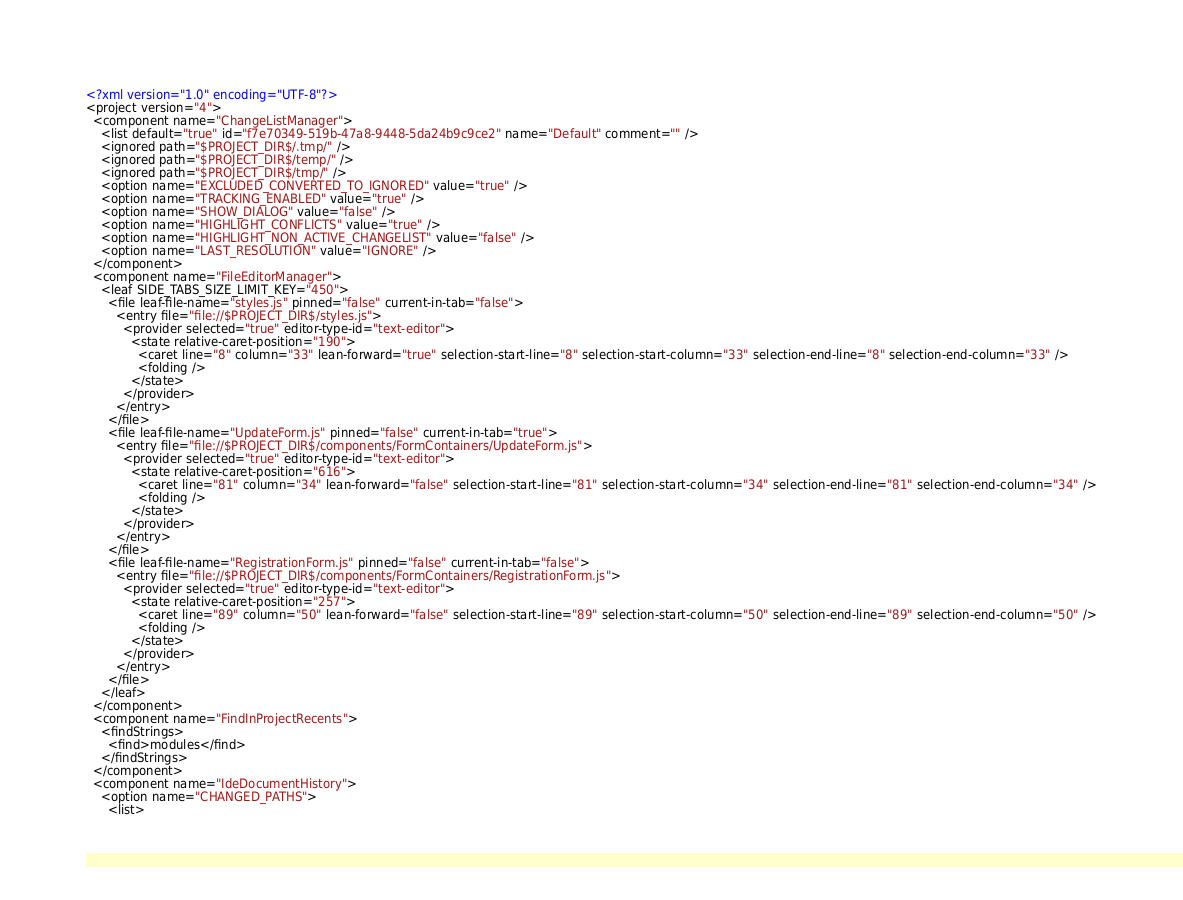<code> <loc_0><loc_0><loc_500><loc_500><_XML_><?xml version="1.0" encoding="UTF-8"?>
<project version="4">
  <component name="ChangeListManager">
    <list default="true" id="f7e70349-519b-47a8-9448-5da24b9c9ce2" name="Default" comment="" />
    <ignored path="$PROJECT_DIR$/.tmp/" />
    <ignored path="$PROJECT_DIR$/temp/" />
    <ignored path="$PROJECT_DIR$/tmp/" />
    <option name="EXCLUDED_CONVERTED_TO_IGNORED" value="true" />
    <option name="TRACKING_ENABLED" value="true" />
    <option name="SHOW_DIALOG" value="false" />
    <option name="HIGHLIGHT_CONFLICTS" value="true" />
    <option name="HIGHLIGHT_NON_ACTIVE_CHANGELIST" value="false" />
    <option name="LAST_RESOLUTION" value="IGNORE" />
  </component>
  <component name="FileEditorManager">
    <leaf SIDE_TABS_SIZE_LIMIT_KEY="450">
      <file leaf-file-name="styles.js" pinned="false" current-in-tab="false">
        <entry file="file://$PROJECT_DIR$/styles.js">
          <provider selected="true" editor-type-id="text-editor">
            <state relative-caret-position="190">
              <caret line="8" column="33" lean-forward="true" selection-start-line="8" selection-start-column="33" selection-end-line="8" selection-end-column="33" />
              <folding />
            </state>
          </provider>
        </entry>
      </file>
      <file leaf-file-name="UpdateForm.js" pinned="false" current-in-tab="true">
        <entry file="file://$PROJECT_DIR$/components/FormContainers/UpdateForm.js">
          <provider selected="true" editor-type-id="text-editor">
            <state relative-caret-position="616">
              <caret line="81" column="34" lean-forward="false" selection-start-line="81" selection-start-column="34" selection-end-line="81" selection-end-column="34" />
              <folding />
            </state>
          </provider>
        </entry>
      </file>
      <file leaf-file-name="RegistrationForm.js" pinned="false" current-in-tab="false">
        <entry file="file://$PROJECT_DIR$/components/FormContainers/RegistrationForm.js">
          <provider selected="true" editor-type-id="text-editor">
            <state relative-caret-position="257">
              <caret line="89" column="50" lean-forward="false" selection-start-line="89" selection-start-column="50" selection-end-line="89" selection-end-column="50" />
              <folding />
            </state>
          </provider>
        </entry>
      </file>
    </leaf>
  </component>
  <component name="FindInProjectRecents">
    <findStrings>
      <find>modules</find>
    </findStrings>
  </component>
  <component name="IdeDocumentHistory">
    <option name="CHANGED_PATHS">
      <list></code> 